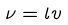<formula> <loc_0><loc_0><loc_500><loc_500>\nu = l v</formula> 